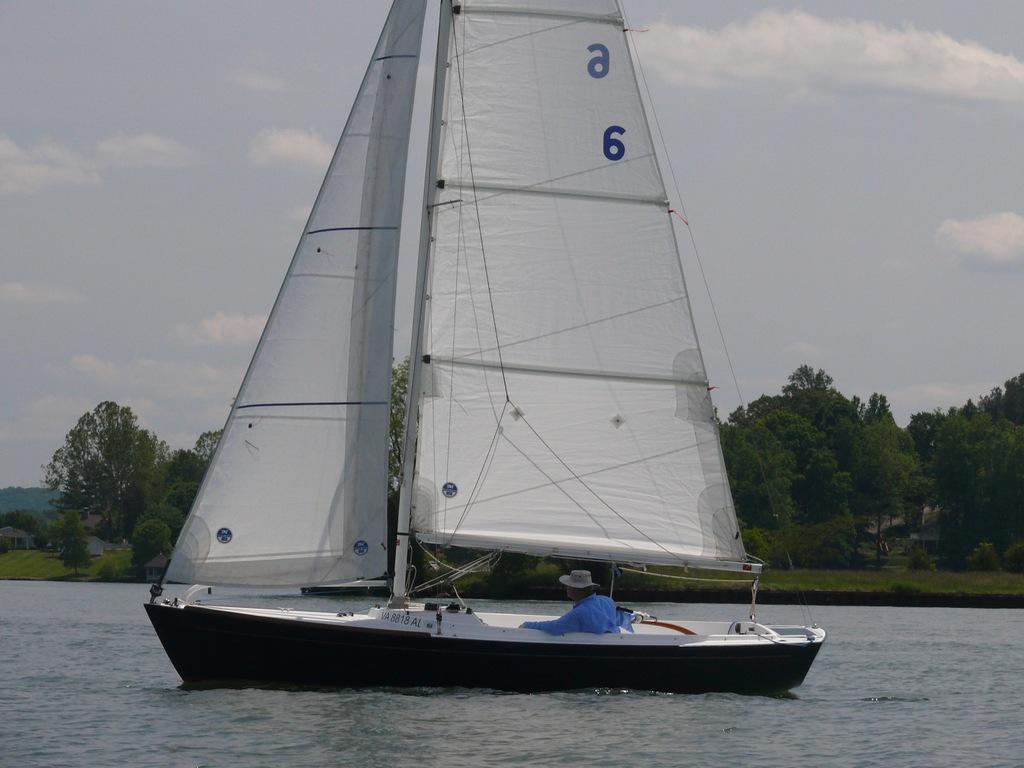<image>
Present a compact description of the photo's key features. A sailboat with an a and a 6 on the sail. 